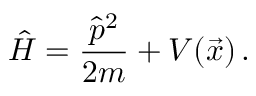<formula> <loc_0><loc_0><loc_500><loc_500>\hat { H } = \frac { \hat { p } ^ { 2 } } { 2 m } + V ( \vec { x } ) \, .</formula> 